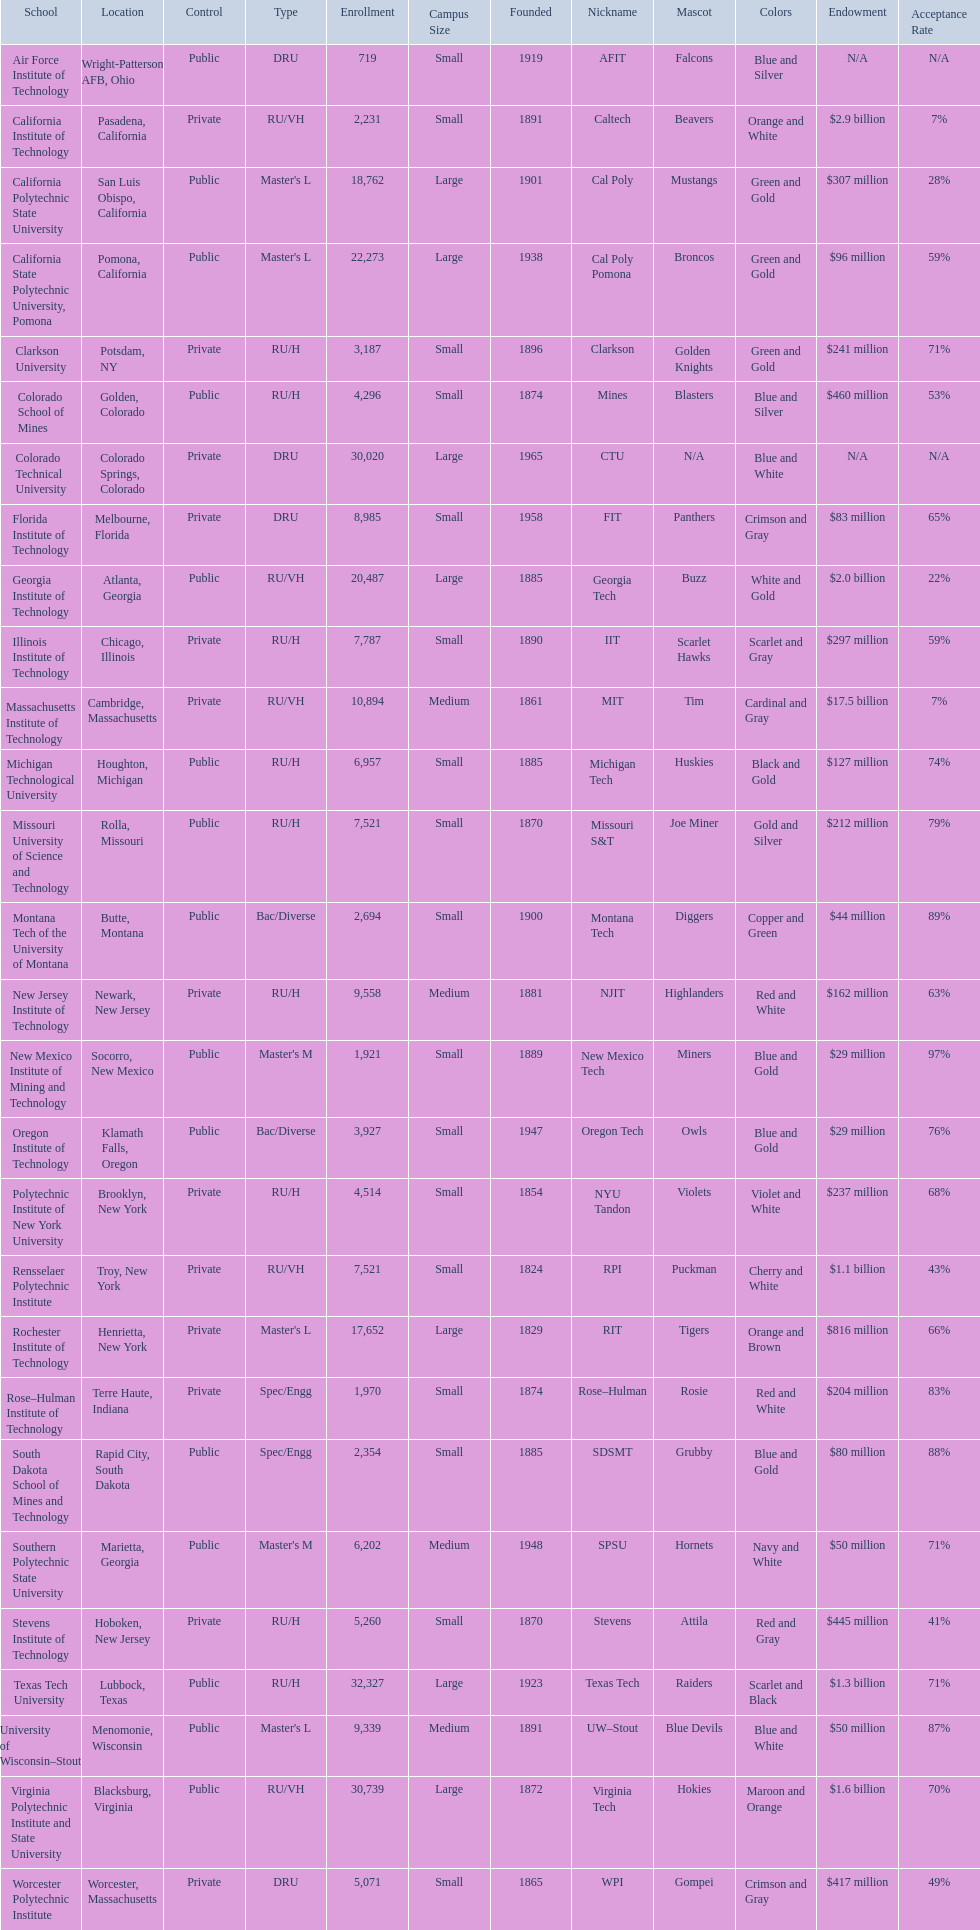What are the listed enrollment numbers of us universities? 719, 2,231, 18,762, 22,273, 3,187, 4,296, 30,020, 8,985, 20,487, 7,787, 10,894, 6,957, 7,521, 2,694, 9,558, 1,921, 3,927, 4,514, 7,521, 17,652, 1,970, 2,354, 6,202, 5,260, 32,327, 9,339, 30,739, 5,071. Of these, which has the highest value? 32,327. What are the listed names of us universities? Air Force Institute of Technology, California Institute of Technology, California Polytechnic State University, California State Polytechnic University, Pomona, Clarkson University, Colorado School of Mines, Colorado Technical University, Florida Institute of Technology, Georgia Institute of Technology, Illinois Institute of Technology, Massachusetts Institute of Technology, Michigan Technological University, Missouri University of Science and Technology, Montana Tech of the University of Montana, New Jersey Institute of Technology, New Mexico Institute of Mining and Technology, Oregon Institute of Technology, Polytechnic Institute of New York University, Rensselaer Polytechnic Institute, Rochester Institute of Technology, Rose–Hulman Institute of Technology, South Dakota School of Mines and Technology, Southern Polytechnic State University, Stevens Institute of Technology, Texas Tech University, University of Wisconsin–Stout, Virginia Polytechnic Institute and State University, Worcester Polytechnic Institute. Which of these correspond to the previously listed highest enrollment value? Texas Tech University. 